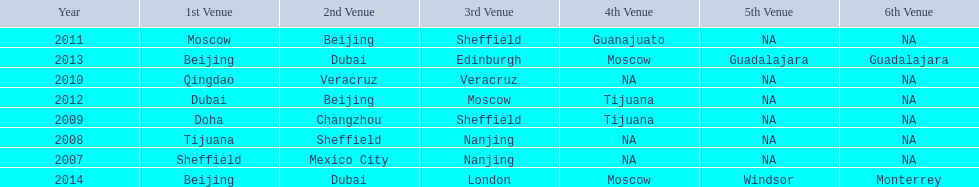In list of venues, how many years was beijing above moscow (1st venue is above 2nd venue, etc)? 3. 